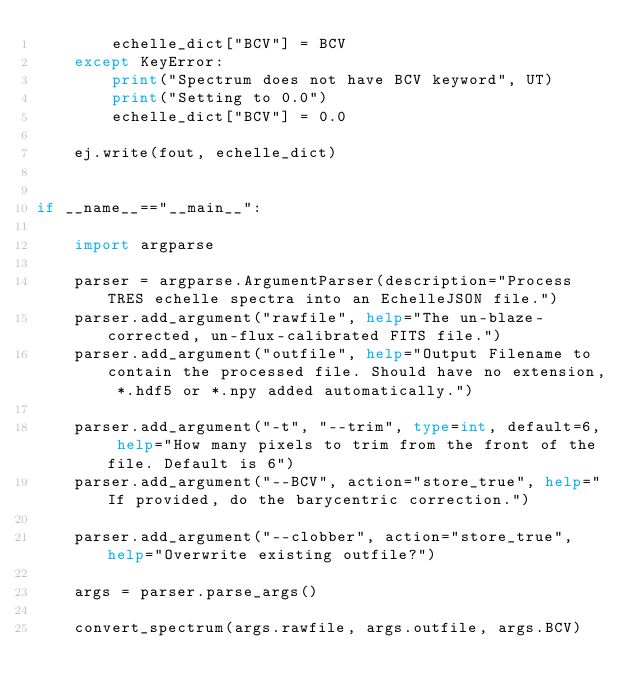<code> <loc_0><loc_0><loc_500><loc_500><_Python_>        echelle_dict["BCV"] = BCV
    except KeyError:
        print("Spectrum does not have BCV keyword", UT)
        print("Setting to 0.0")
        echelle_dict["BCV"] = 0.0

    ej.write(fout, echelle_dict)


if __name__=="__main__":

    import argparse

    parser = argparse.ArgumentParser(description="Process TRES echelle spectra into an EchelleJSON file.")
    parser.add_argument("rawfile", help="The un-blaze-corrected, un-flux-calibrated FITS file.")
    parser.add_argument("outfile", help="Output Filename to contain the processed file. Should have no extension, *.hdf5 or *.npy added automatically.")

    parser.add_argument("-t", "--trim", type=int, default=6, help="How many pixels to trim from the front of the file. Default is 6")
    parser.add_argument("--BCV", action="store_true", help="If provided, do the barycentric correction.")

    parser.add_argument("--clobber", action="store_true", help="Overwrite existing outfile?")

    args = parser.parse_args()

    convert_spectrum(args.rawfile, args.outfile, args.BCV)
</code> 